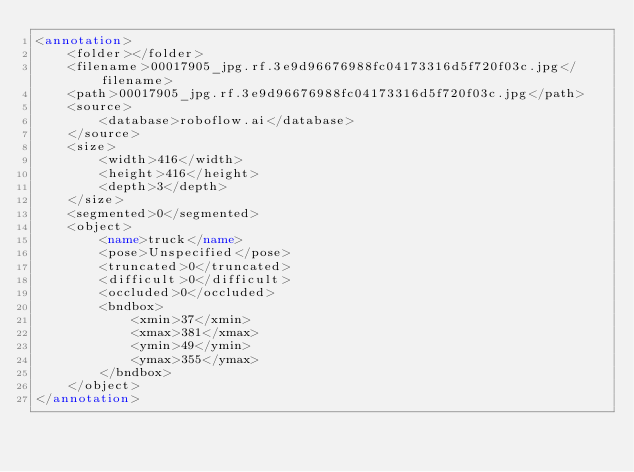Convert code to text. <code><loc_0><loc_0><loc_500><loc_500><_XML_><annotation>
	<folder></folder>
	<filename>00017905_jpg.rf.3e9d96676988fc04173316d5f720f03c.jpg</filename>
	<path>00017905_jpg.rf.3e9d96676988fc04173316d5f720f03c.jpg</path>
	<source>
		<database>roboflow.ai</database>
	</source>
	<size>
		<width>416</width>
		<height>416</height>
		<depth>3</depth>
	</size>
	<segmented>0</segmented>
	<object>
		<name>truck</name>
		<pose>Unspecified</pose>
		<truncated>0</truncated>
		<difficult>0</difficult>
		<occluded>0</occluded>
		<bndbox>
			<xmin>37</xmin>
			<xmax>381</xmax>
			<ymin>49</ymin>
			<ymax>355</ymax>
		</bndbox>
	</object>
</annotation>
</code> 